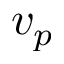Convert formula to latex. <formula><loc_0><loc_0><loc_500><loc_500>v _ { p }</formula> 